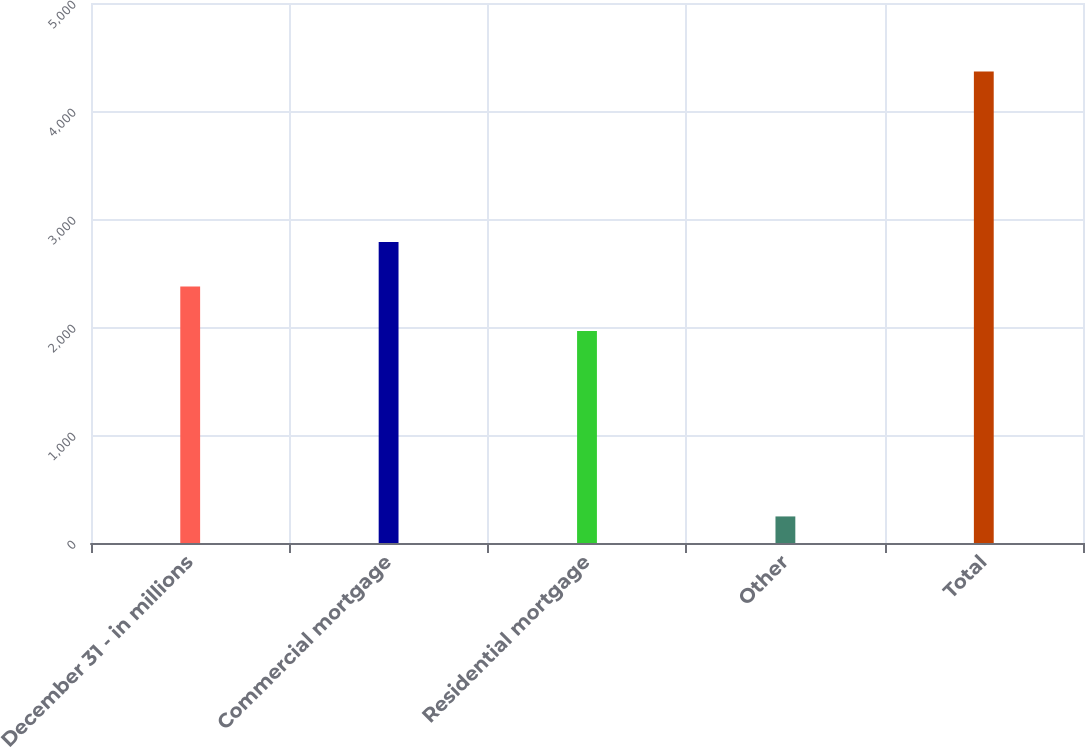Convert chart. <chart><loc_0><loc_0><loc_500><loc_500><bar_chart><fcel>December 31 - in millions<fcel>Commercial mortgage<fcel>Residential mortgage<fcel>Other<fcel>Total<nl><fcel>2374<fcel>2786<fcel>1962<fcel>246<fcel>4366<nl></chart> 